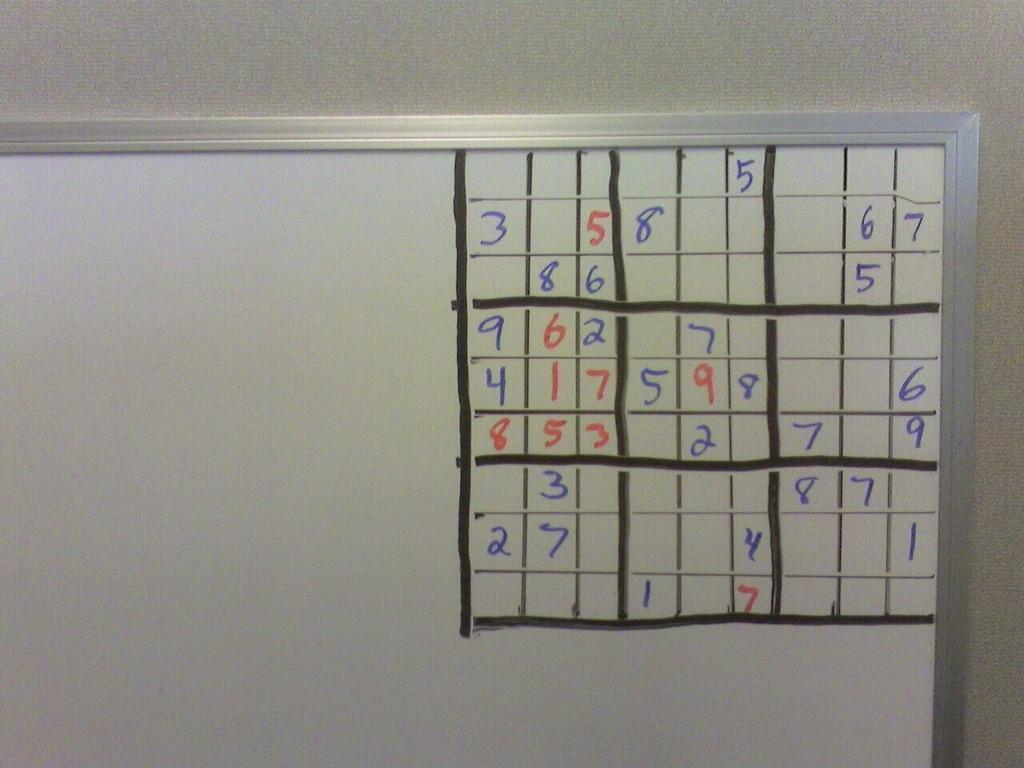What is the number in the top row?
Keep it short and to the point. 5. Which numbers are on the bottom row?
Your answer should be compact. 17. 